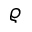Convert formula to latex. <formula><loc_0><loc_0><loc_500><loc_500>\varrho</formula> 